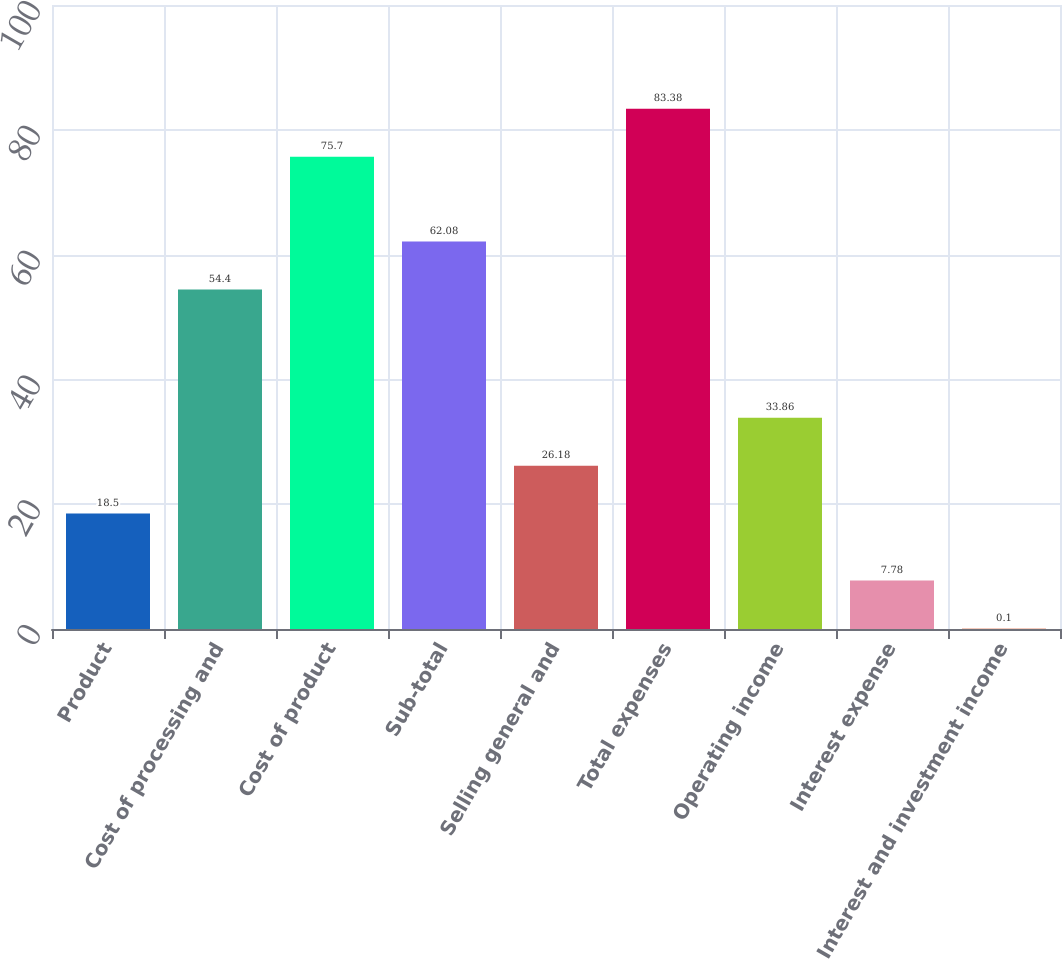Convert chart. <chart><loc_0><loc_0><loc_500><loc_500><bar_chart><fcel>Product<fcel>Cost of processing and<fcel>Cost of product<fcel>Sub-total<fcel>Selling general and<fcel>Total expenses<fcel>Operating income<fcel>Interest expense<fcel>Interest and investment income<nl><fcel>18.5<fcel>54.4<fcel>75.7<fcel>62.08<fcel>26.18<fcel>83.38<fcel>33.86<fcel>7.78<fcel>0.1<nl></chart> 